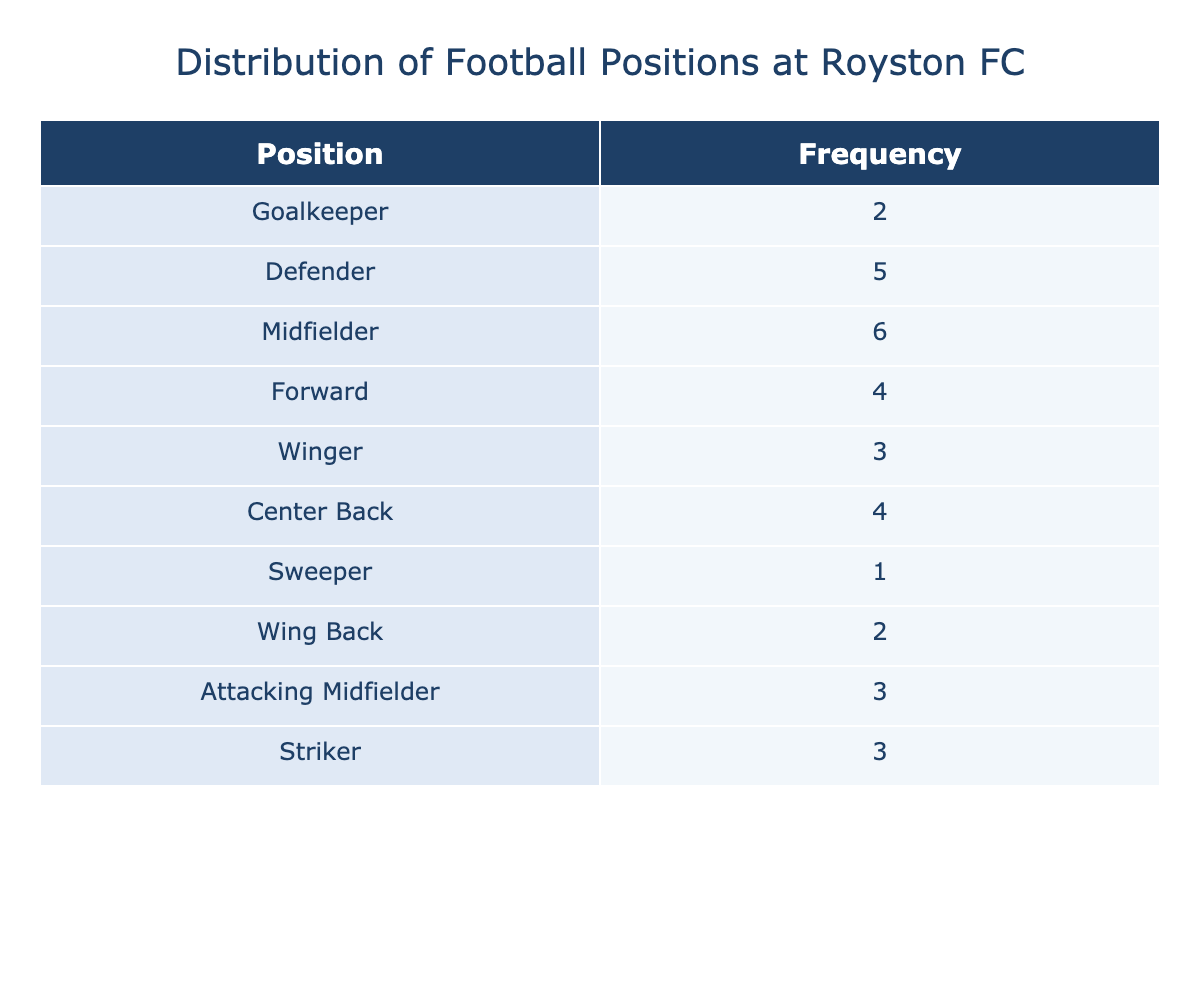What is the frequency of midfielders at Royston FC? The table indicates that there are 6 midfielders, as stated in the Frequency column next to the Midfielder position.
Answer: 6 Which position has the highest frequency in the table? By examining the Frequency column, I can see that the Midfielder position has the highest count with a frequency of 6.
Answer: Midfielder Are there more defenders or forwards at Royston FC? The table shows that there are 5 defenders and 4 forwards. Comparing these values, defenders are greater than forwards.
Answer: Yes What is the total number of players playing as goalkeepers and sweepers combined? The frequency for goalkeepers is 2 and for sweepers, it is 1. Adding these, 2 + 1 equals 3. Therefore, the total number is 3.
Answer: 3 What percentage of Royston FC players are midfielders? First, I need to calculate the total number of players by summing up the frequencies: 2 + 5 + 6 + 4 + 3 + 4 + 1 + 2 + 3 + 3 = 33. The number of midfielders is 6. The percentage is (6/33) * 100, which gives approximately 18.18%.
Answer: 18.18% Is there a position with a frequency of only one player? Looking at the table, the Sweeper position has a frequency of 1, making it a position with only one player.
Answer: Yes What is the difference in frequency between the most and least common positions? The most common position is Midfielder with a frequency of 6, and the least common is Sweeper with a frequency of 1. The difference is 6 - 1 = 5.
Answer: 5 How many players are Wingers and Center Backs combined? By looking at the table, there are 3 Wingers and 4 Center Backs. Adding them together, 3 + 4 results in 7.
Answer: 7 What is the mode of the football positions based on the frequency? The mode is the position that occurs the most frequently; Midfielder is the mode with a frequency of 6, as it is higher than any other position's frequency.
Answer: Midfielder 